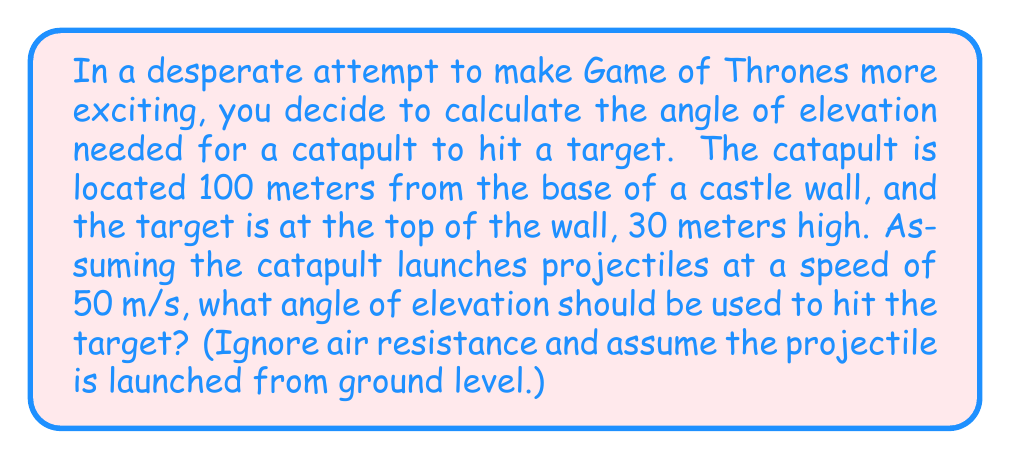Could you help me with this problem? Let's approach this step-by-step:

1) We can use the equation of projectile motion:
   $$y = x \tan \theta - \frac{gx^2}{2v^2\cos^2\theta}$$
   where $y$ is the vertical distance, $x$ is the horizontal distance, $\theta$ is the angle of elevation, $g$ is the acceleration due to gravity (9.8 m/s²), and $v$ is the initial velocity.

2) We know:
   $x = 100$ m
   $y = 30$ m
   $v = 50$ m/s
   $g = 9.8$ m/s²

3) Substituting these values into the equation:
   $$30 = 100 \tan \theta - \frac{9.8(100)^2}{2(50)^2\cos^2\theta}$$

4) Simplifying:
   $$30 = 100 \tan \theta - \frac{98000}{5000\cos^2\theta}$$

5) Multiplying both sides by $5000\cos^2\theta$:
   $$150000\cos^2\theta = 500000\sin\theta\cos\theta - 98000$$

6) Using the identity $\sin 2\theta = 2\sin\theta\cos\theta$:
   $$150000\cos^2\theta = 250000\sin 2\theta - 98000$$

7) This equation can be solved numerically. Using a calculator or computer, we find:
   $$\theta \approx 0.5404 \text{ radians}$$

8) Converting to degrees:
   $$\theta \approx 30.97°$$
Answer: $30.97°$ 